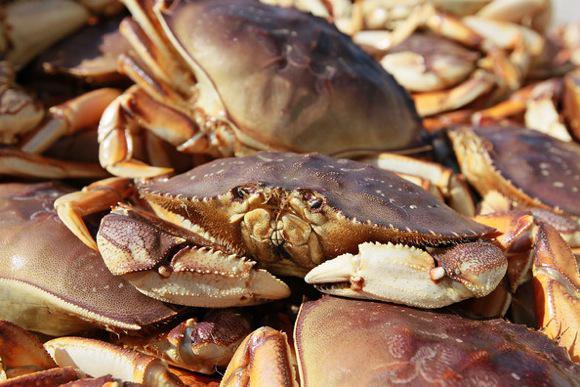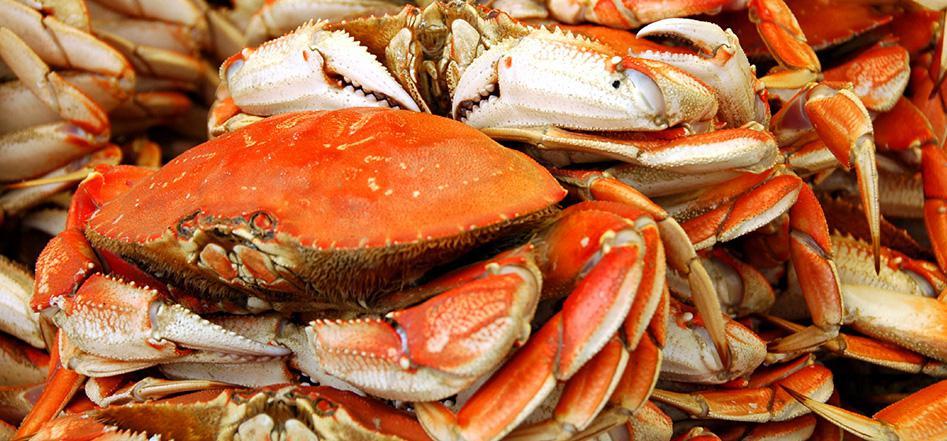The first image is the image on the left, the second image is the image on the right. Assess this claim about the two images: "A hand is holding onto a crab in at least one image, and a crab is on a wooden board in the right image.". Correct or not? Answer yes or no. No. The first image is the image on the left, the second image is the image on the right. Examine the images to the left and right. Is the description "A person is holding up the crab in the image on the left." accurate? Answer yes or no. No. 